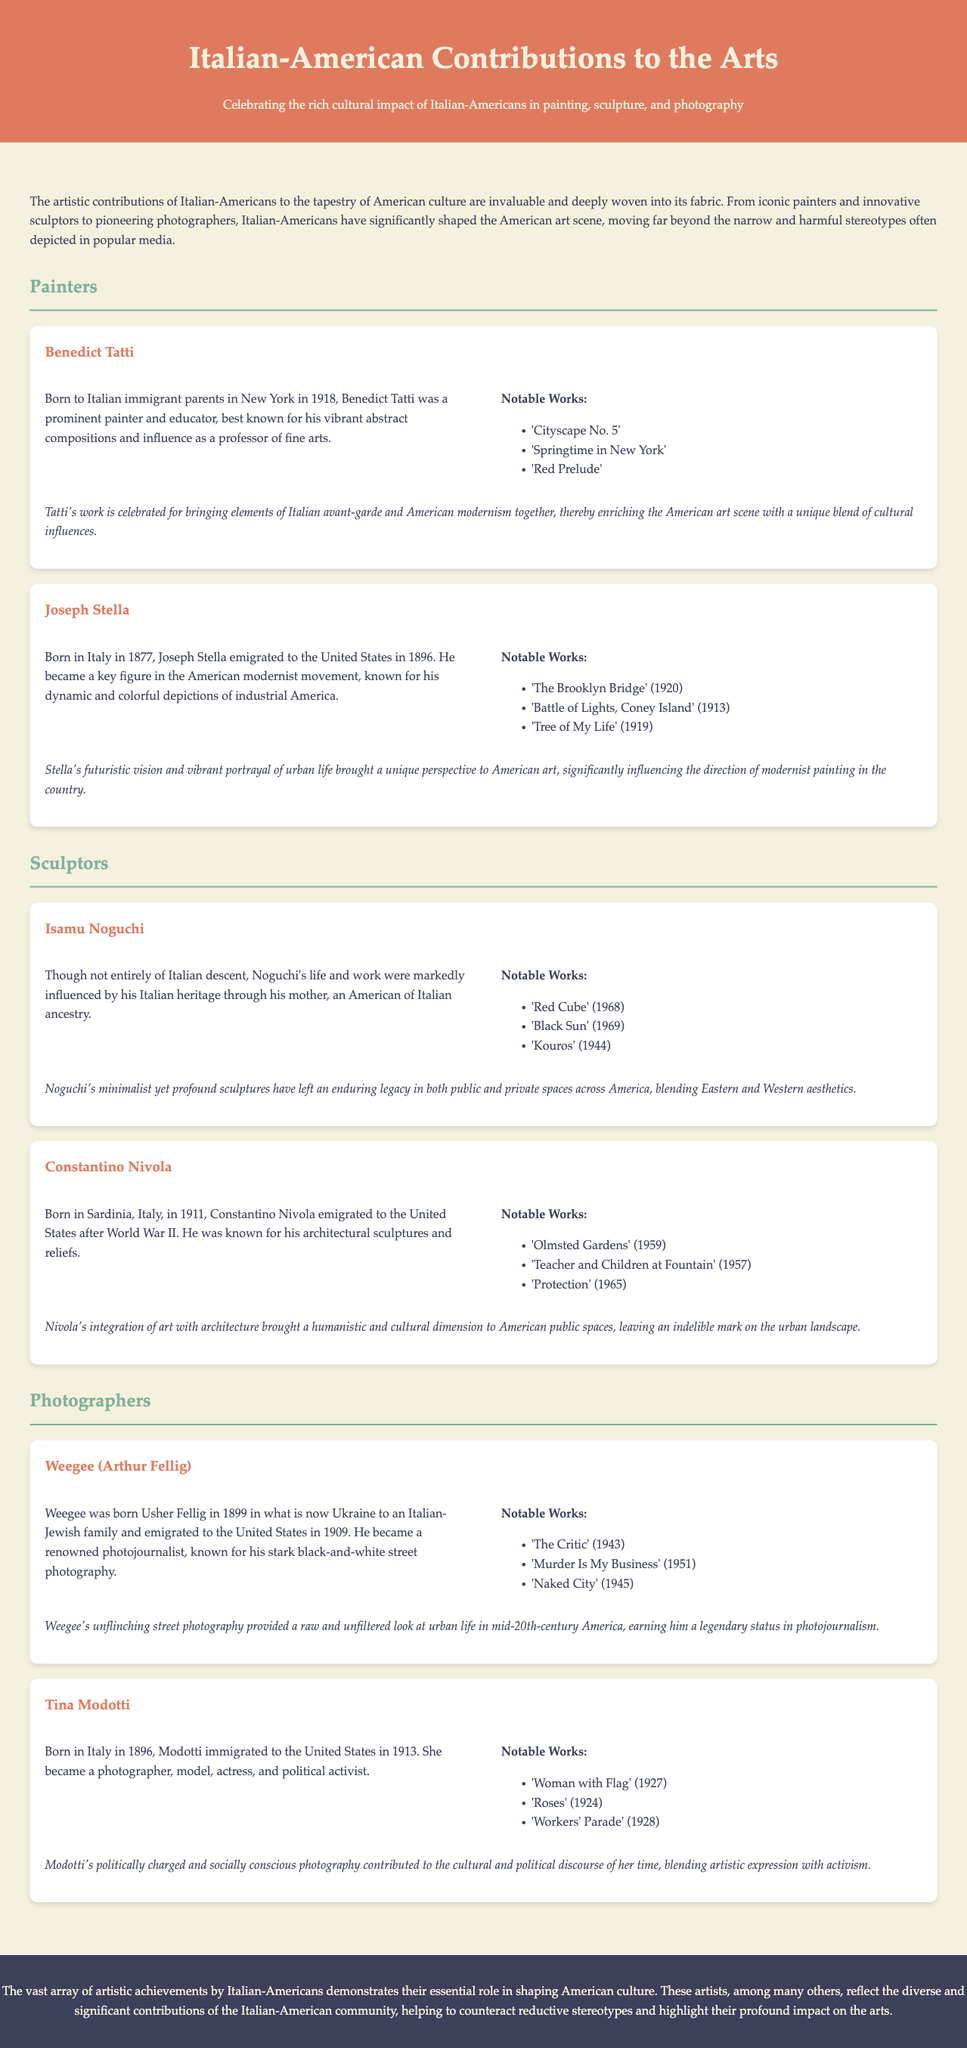What is the birth year of Benedict Tatti? Benedict Tatti was born in 1918 according to the document.
Answer: 1918 Which Italian-American artist is known for the work "The Brooklyn Bridge"? Joseph Stella is recognized for his painting "The Brooklyn Bridge" as mentioned in the document.
Answer: Joseph Stella What is the main artistic focus of Isamu Noguchi? Isamu Noguchi's work primarily focused on minimalist sculptures as described in the document.
Answer: Minimalist sculptures Which artist's notable work includes "Woman with Flag"? Tina Modotti is the artist who created "Woman with Flag" listed in the document.
Answer: Tina Modotti What year was Weegee born? Weegee was born in 1899 according to the document.
Answer: 1899 How many notable works are listed for Constantino Nivola? The document mentions three notable works for Constantino Nivola.
Answer: Three What cultural background influenced Isamu Noguchi? Isamu Noguchi was influenced by his Italian heritage through his mother, as stated in the document.
Answer: Italian heritage Which artist is associated with the term "photojournalism"? Weegee is identified with being a renowned photojournalist in the document.
Answer: Weegee 